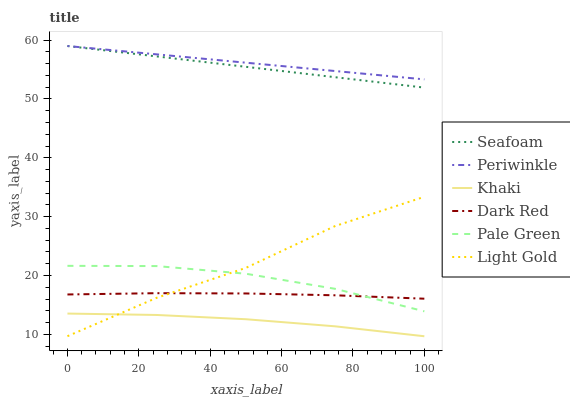Does Khaki have the minimum area under the curve?
Answer yes or no. Yes. Does Periwinkle have the maximum area under the curve?
Answer yes or no. Yes. Does Dark Red have the minimum area under the curve?
Answer yes or no. No. Does Dark Red have the maximum area under the curve?
Answer yes or no. No. Is Seafoam the smoothest?
Answer yes or no. Yes. Is Light Gold the roughest?
Answer yes or no. Yes. Is Dark Red the smoothest?
Answer yes or no. No. Is Dark Red the roughest?
Answer yes or no. No. Does Dark Red have the lowest value?
Answer yes or no. No. Does Dark Red have the highest value?
Answer yes or no. No. Is Khaki less than Dark Red?
Answer yes or no. Yes. Is Seafoam greater than Khaki?
Answer yes or no. Yes. Does Khaki intersect Dark Red?
Answer yes or no. No. 